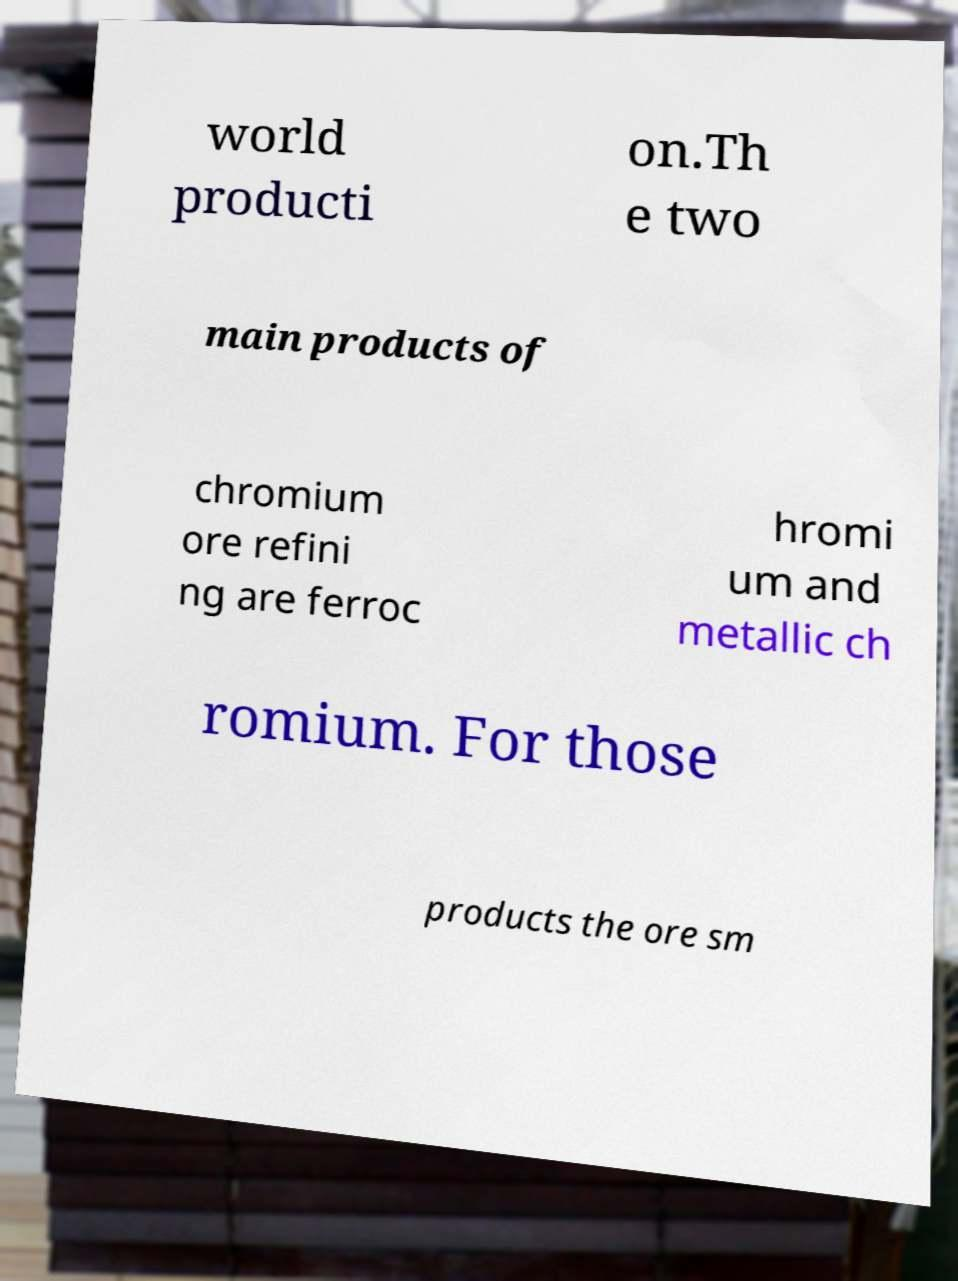Could you assist in decoding the text presented in this image and type it out clearly? world producti on.Th e two main products of chromium ore refini ng are ferroc hromi um and metallic ch romium. For those products the ore sm 